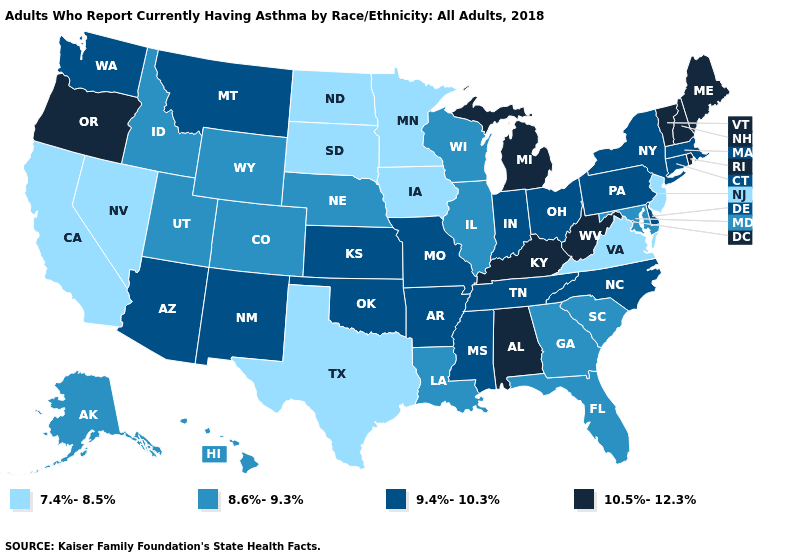What is the lowest value in the USA?
Concise answer only. 7.4%-8.5%. Among the states that border California , does Arizona have the lowest value?
Answer briefly. No. Which states have the lowest value in the USA?
Keep it brief. California, Iowa, Minnesota, Nevada, New Jersey, North Dakota, South Dakota, Texas, Virginia. Among the states that border Louisiana , which have the highest value?
Keep it brief. Arkansas, Mississippi. Name the states that have a value in the range 9.4%-10.3%?
Be succinct. Arizona, Arkansas, Connecticut, Delaware, Indiana, Kansas, Massachusetts, Mississippi, Missouri, Montana, New Mexico, New York, North Carolina, Ohio, Oklahoma, Pennsylvania, Tennessee, Washington. Does Washington have the same value as Rhode Island?
Answer briefly. No. Does New Mexico have the highest value in the West?
Write a very short answer. No. What is the value of Michigan?
Keep it brief. 10.5%-12.3%. What is the highest value in the Northeast ?
Keep it brief. 10.5%-12.3%. Name the states that have a value in the range 10.5%-12.3%?
Concise answer only. Alabama, Kentucky, Maine, Michigan, New Hampshire, Oregon, Rhode Island, Vermont, West Virginia. What is the value of Washington?
Give a very brief answer. 9.4%-10.3%. Among the states that border Nebraska , does Colorado have the lowest value?
Keep it brief. No. Name the states that have a value in the range 10.5%-12.3%?
Quick response, please. Alabama, Kentucky, Maine, Michigan, New Hampshire, Oregon, Rhode Island, Vermont, West Virginia. Among the states that border Vermont , does New York have the lowest value?
Write a very short answer. Yes. 